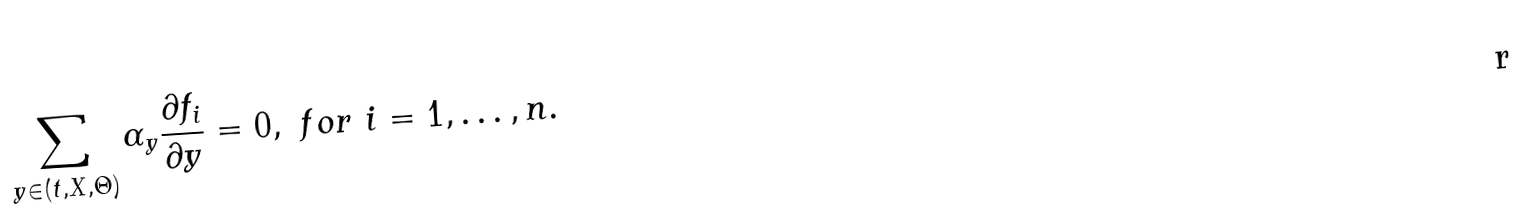<formula> <loc_0><loc_0><loc_500><loc_500>\sum _ { y \in ( t , X , \Theta ) } \alpha _ { y } \frac { \partial f _ { i } } { \partial y } = 0 , \ f o r \ i = 1 , \dots , n .</formula> 